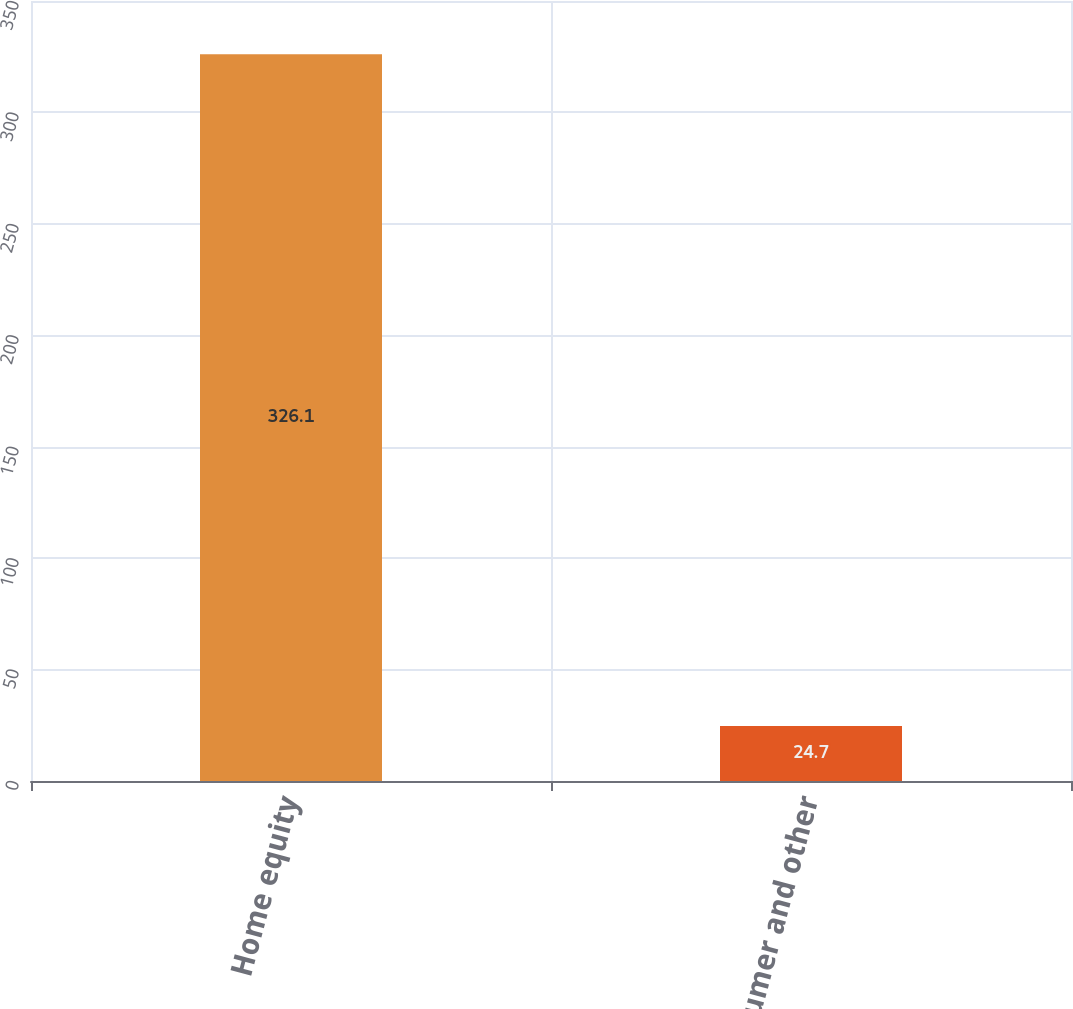Convert chart. <chart><loc_0><loc_0><loc_500><loc_500><bar_chart><fcel>Home equity<fcel>Consumer and other<nl><fcel>326.1<fcel>24.7<nl></chart> 